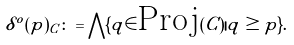Convert formula to latex. <formula><loc_0><loc_0><loc_500><loc_500>\delta ^ { o } ( p ) _ { C } \colon = \bigwedge \{ q \in \text {Proj} ( C ) | q \geq p \} .</formula> 